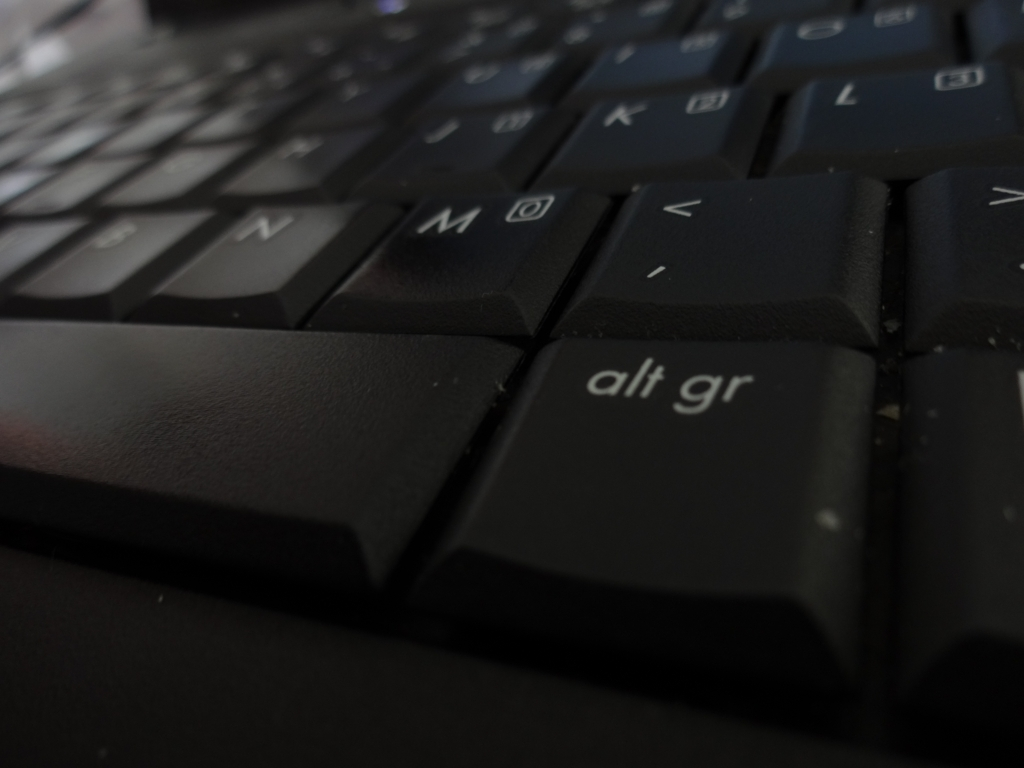What could be the reason for the dust particles on the keyboard? The dust particles visible on the keyboard keys suggest that the keyboard has been exposed to a typical amount of airborne dust over time, which is common in most environments. It may indicate that the keyboard hasn't been cleaned recently or is frequently used in a setting where dust accumulates quickly. 